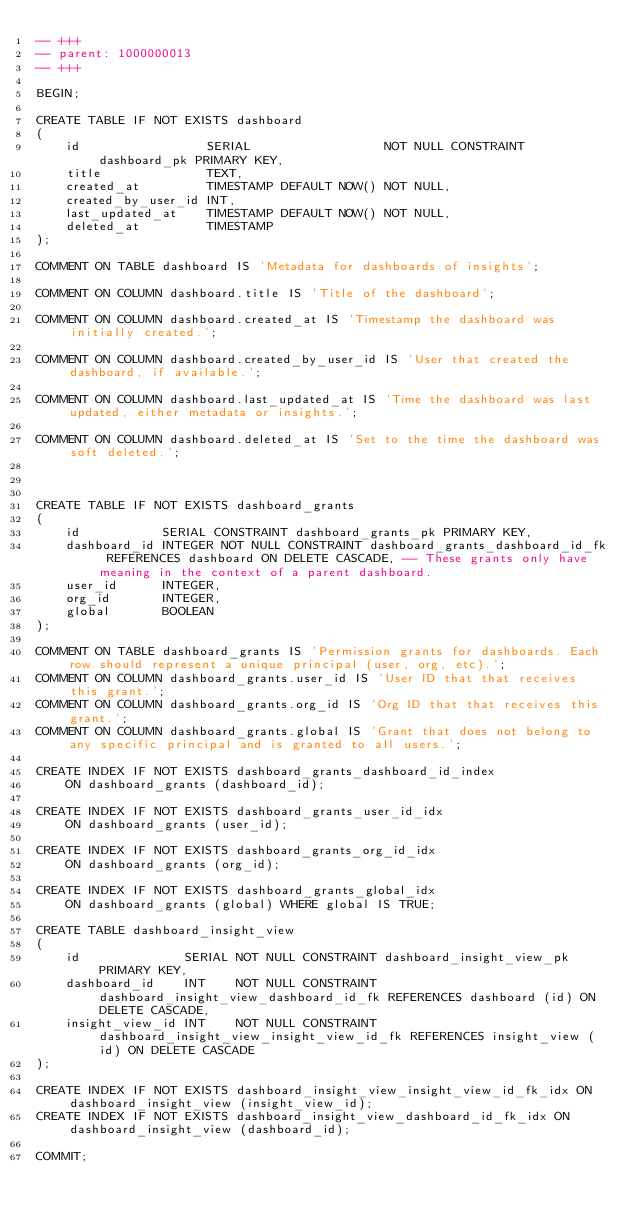Convert code to text. <code><loc_0><loc_0><loc_500><loc_500><_SQL_>-- +++
-- parent: 1000000013
-- +++

BEGIN;

CREATE TABLE IF NOT EXISTS dashboard
(
    id                 SERIAL                  NOT NULL CONSTRAINT dashboard_pk PRIMARY KEY,
    title              TEXT,
    created_at         TIMESTAMP DEFAULT NOW() NOT NULL,
    created_by_user_id INT,
    last_updated_at    TIMESTAMP DEFAULT NOW() NOT NULL,
    deleted_at         TIMESTAMP
);

COMMENT ON TABLE dashboard IS 'Metadata for dashboards of insights';

COMMENT ON COLUMN dashboard.title IS 'Title of the dashboard';

COMMENT ON COLUMN dashboard.created_at IS 'Timestamp the dashboard was initially created.';

COMMENT ON COLUMN dashboard.created_by_user_id IS 'User that created the dashboard, if available.';

COMMENT ON COLUMN dashboard.last_updated_at IS 'Time the dashboard was last updated, either metadata or insights.';

COMMENT ON COLUMN dashboard.deleted_at IS 'Set to the time the dashboard was soft deleted.';



CREATE TABLE IF NOT EXISTS dashboard_grants
(
    id           SERIAL CONSTRAINT dashboard_grants_pk PRIMARY KEY,
    dashboard_id INTEGER NOT NULL CONSTRAINT dashboard_grants_dashboard_id_fk REFERENCES dashboard ON DELETE CASCADE, -- These grants only have meaning in the context of a parent dashboard.
    user_id      INTEGER,
    org_id       INTEGER,
    global       BOOLEAN
);

COMMENT ON TABLE dashboard_grants IS 'Permission grants for dashboards. Each row should represent a unique principal (user, org, etc).';
COMMENT ON COLUMN dashboard_grants.user_id IS 'User ID that that receives this grant.';
COMMENT ON COLUMN dashboard_grants.org_id IS 'Org ID that that receives this grant.';
COMMENT ON COLUMN dashboard_grants.global IS 'Grant that does not belong to any specific principal and is granted to all users.';

CREATE INDEX IF NOT EXISTS dashboard_grants_dashboard_id_index
    ON dashboard_grants (dashboard_id);

CREATE INDEX IF NOT EXISTS dashboard_grants_user_id_idx
    ON dashboard_grants (user_id);

CREATE INDEX IF NOT EXISTS dashboard_grants_org_id_idx
    ON dashboard_grants (org_id);

CREATE INDEX IF NOT EXISTS dashboard_grants_global_idx
    ON dashboard_grants (global) WHERE global IS TRUE;

CREATE TABLE dashboard_insight_view
(
    id              SERIAL NOT NULL CONSTRAINT dashboard_insight_view_pk PRIMARY KEY,
    dashboard_id    INT    NOT NULL CONSTRAINT dashboard_insight_view_dashboard_id_fk REFERENCES dashboard (id) ON DELETE CASCADE,
    insight_view_id INT    NOT NULL CONSTRAINT dashboard_insight_view_insight_view_id_fk REFERENCES insight_view (id) ON DELETE CASCADE
);

CREATE INDEX IF NOT EXISTS dashboard_insight_view_insight_view_id_fk_idx ON dashboard_insight_view (insight_view_id);
CREATE INDEX IF NOT EXISTS dashboard_insight_view_dashboard_id_fk_idx ON dashboard_insight_view (dashboard_id);

COMMIT;
</code> 